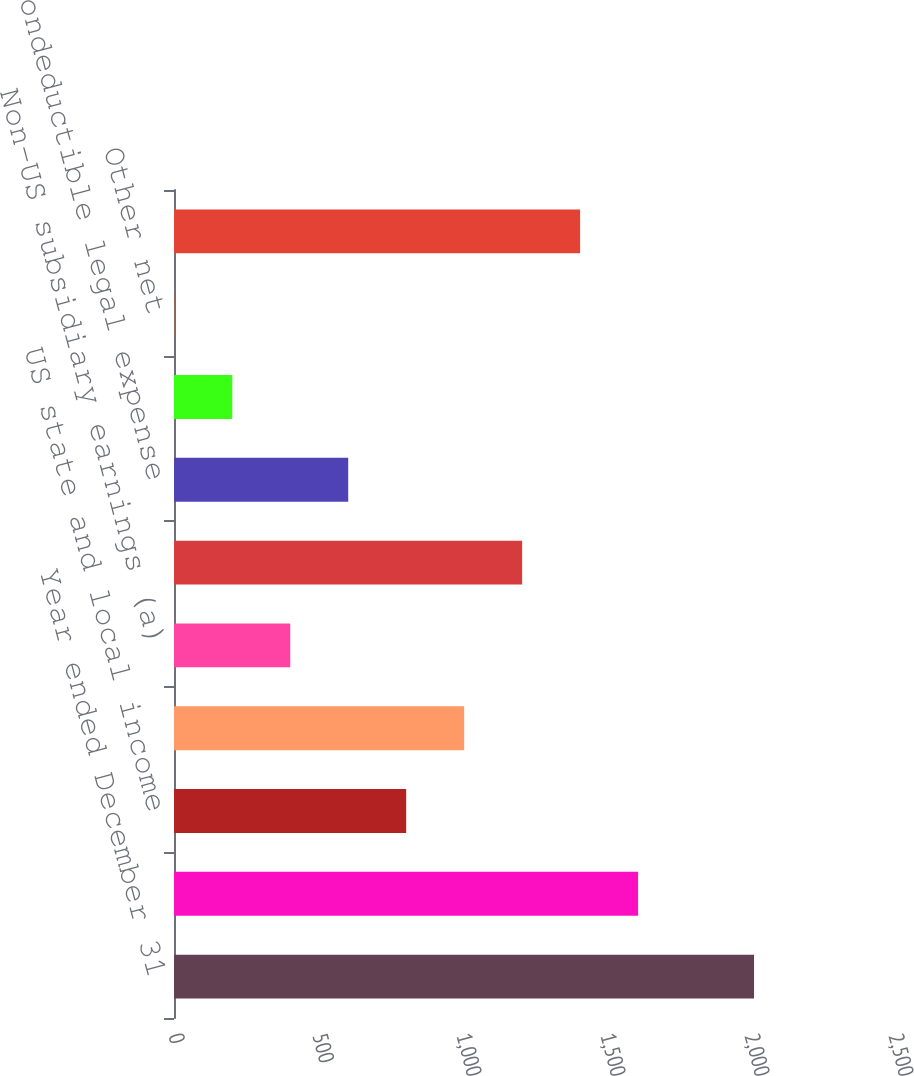Convert chart. <chart><loc_0><loc_0><loc_500><loc_500><bar_chart><fcel>Year ended December 31<fcel>Statutory US federal tax rate<fcel>US state and local income<fcel>Tax-exempt income<fcel>Non-US subsidiary earnings (a)<fcel>Business tax credits<fcel>Nondeductible legal expense<fcel>Tax audit resolutions<fcel>Other net<fcel>Effective tax rate<nl><fcel>2014<fcel>1611.4<fcel>806.2<fcel>1007.5<fcel>403.6<fcel>1208.8<fcel>604.9<fcel>202.3<fcel>1<fcel>1410.1<nl></chart> 